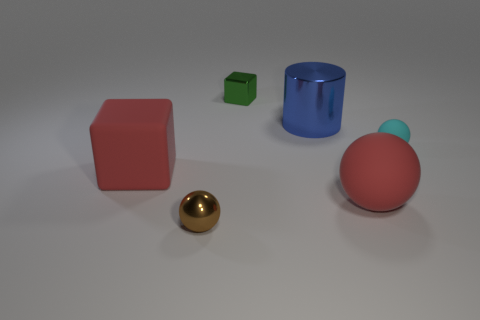Subtract all cyan rubber balls. How many balls are left? 2 Subtract all green cubes. How many cubes are left? 1 Subtract 1 cubes. How many cubes are left? 1 Subtract 0 green cylinders. How many objects are left? 6 Subtract all cylinders. How many objects are left? 5 Subtract all cyan cubes. Subtract all blue balls. How many cubes are left? 2 Subtract all yellow cubes. How many brown cylinders are left? 0 Subtract all small cyan matte balls. Subtract all green metal cubes. How many objects are left? 4 Add 6 red rubber objects. How many red rubber objects are left? 8 Add 6 shiny cylinders. How many shiny cylinders exist? 7 